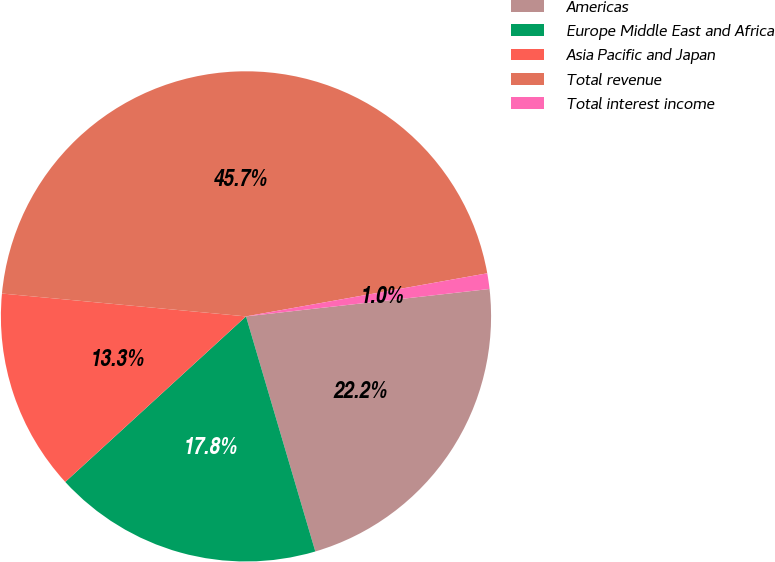Convert chart to OTSL. <chart><loc_0><loc_0><loc_500><loc_500><pie_chart><fcel>Americas<fcel>Europe Middle East and Africa<fcel>Asia Pacific and Japan<fcel>Total revenue<fcel>Total interest income<nl><fcel>22.22%<fcel>17.76%<fcel>13.29%<fcel>45.7%<fcel>1.03%<nl></chart> 